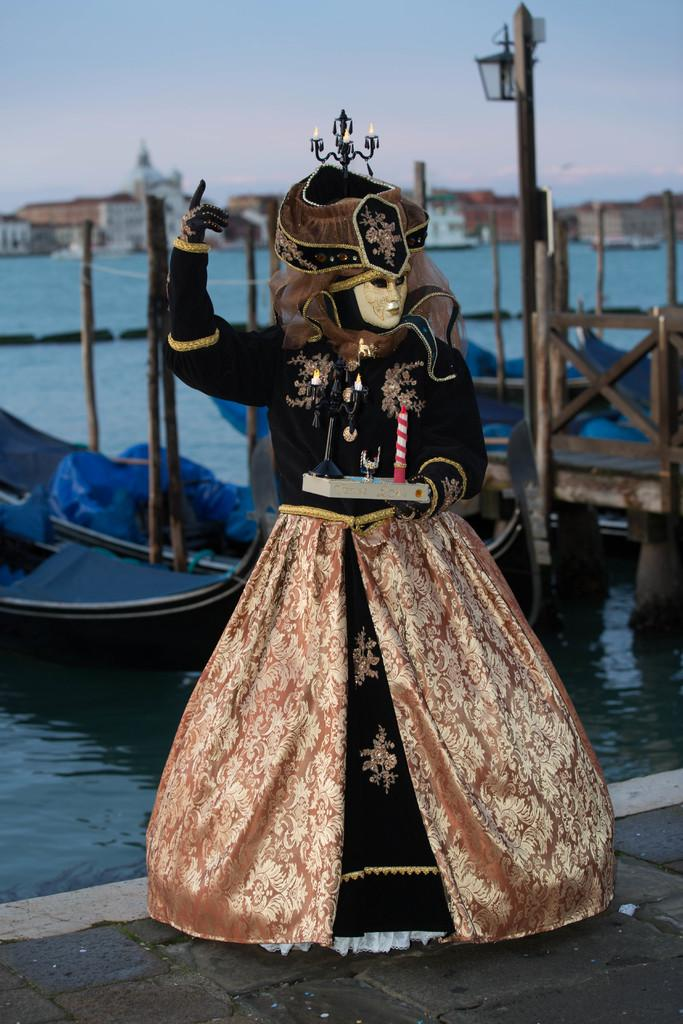What object can be seen in the image that is meant for play? There is a toy in the image. What natural feature is visible in the image? There is a sea visible in the image. What type of structures can be seen in the image? There are houses in the image. What type of soup is being served on the table in the image? There is no table or soup present in the image. How many planes can be seen flying over the houses in the image? There are no planes visible in the image; only a toy, a sea, and houses are present. 